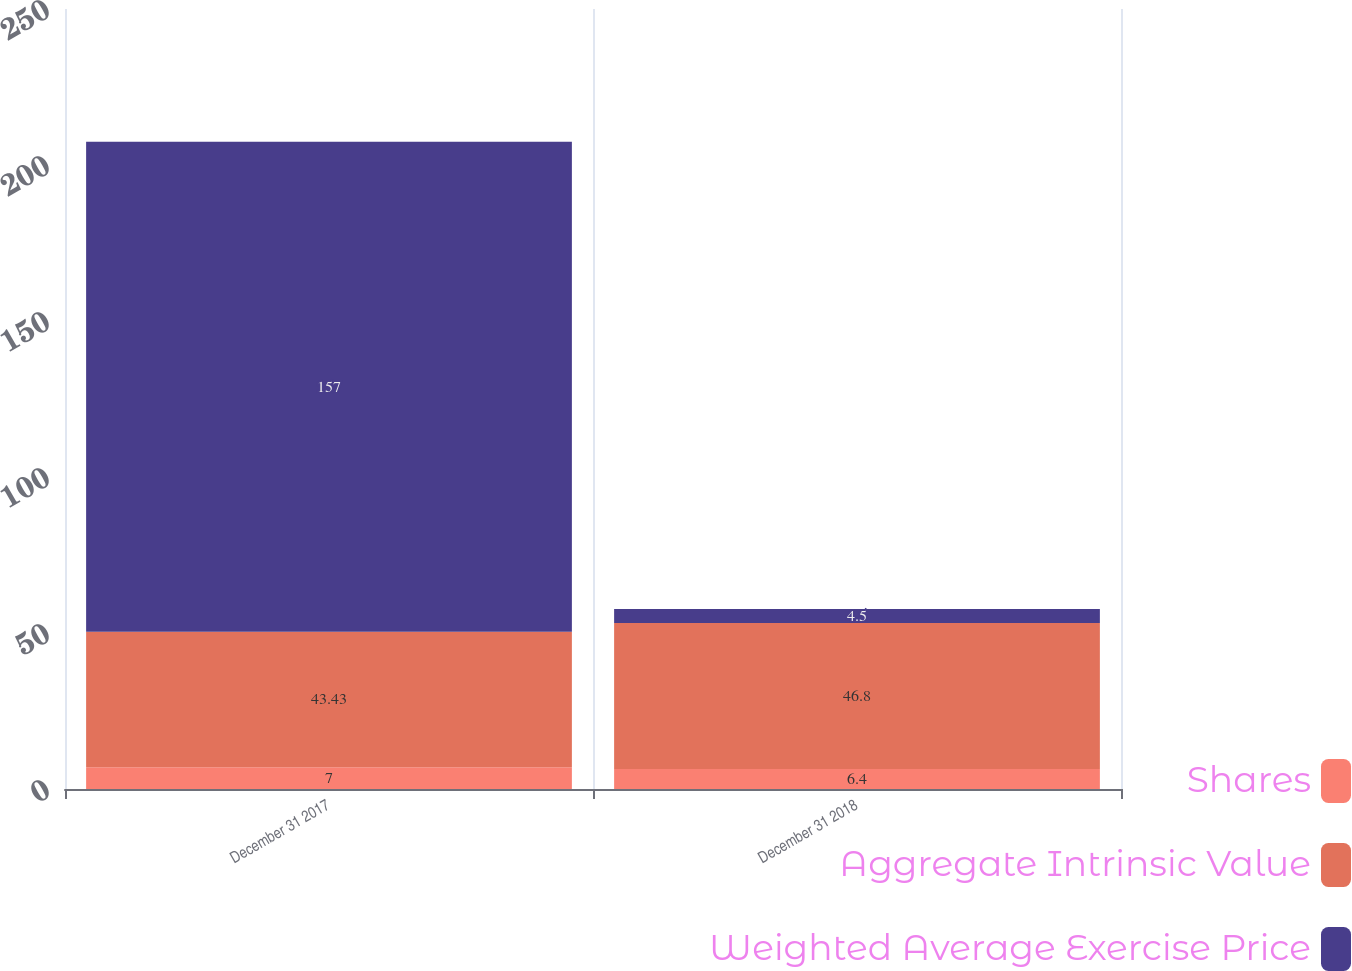Convert chart to OTSL. <chart><loc_0><loc_0><loc_500><loc_500><stacked_bar_chart><ecel><fcel>December 31 2017<fcel>December 31 2018<nl><fcel>Shares<fcel>7<fcel>6.4<nl><fcel>Aggregate Intrinsic Value<fcel>43.43<fcel>46.8<nl><fcel>Weighted Average Exercise Price<fcel>157<fcel>4.5<nl></chart> 